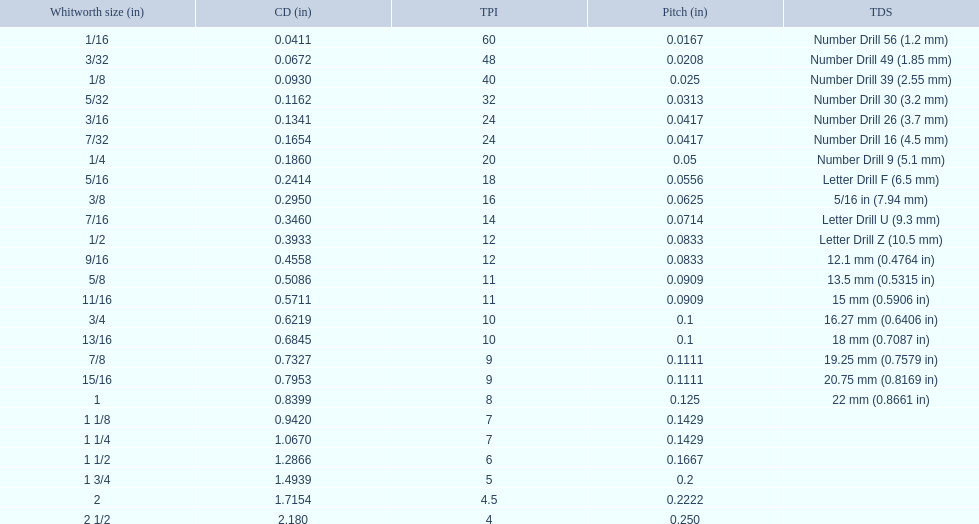What are the sizes of threads per inch? 60, 48, 40, 32, 24, 24, 20, 18, 16, 14, 12, 12, 11, 11, 10, 10, 9, 9, 8, 7, 7, 6, 5, 4.5, 4. Which whitworth size has only 5 threads per inch? 1 3/4. 